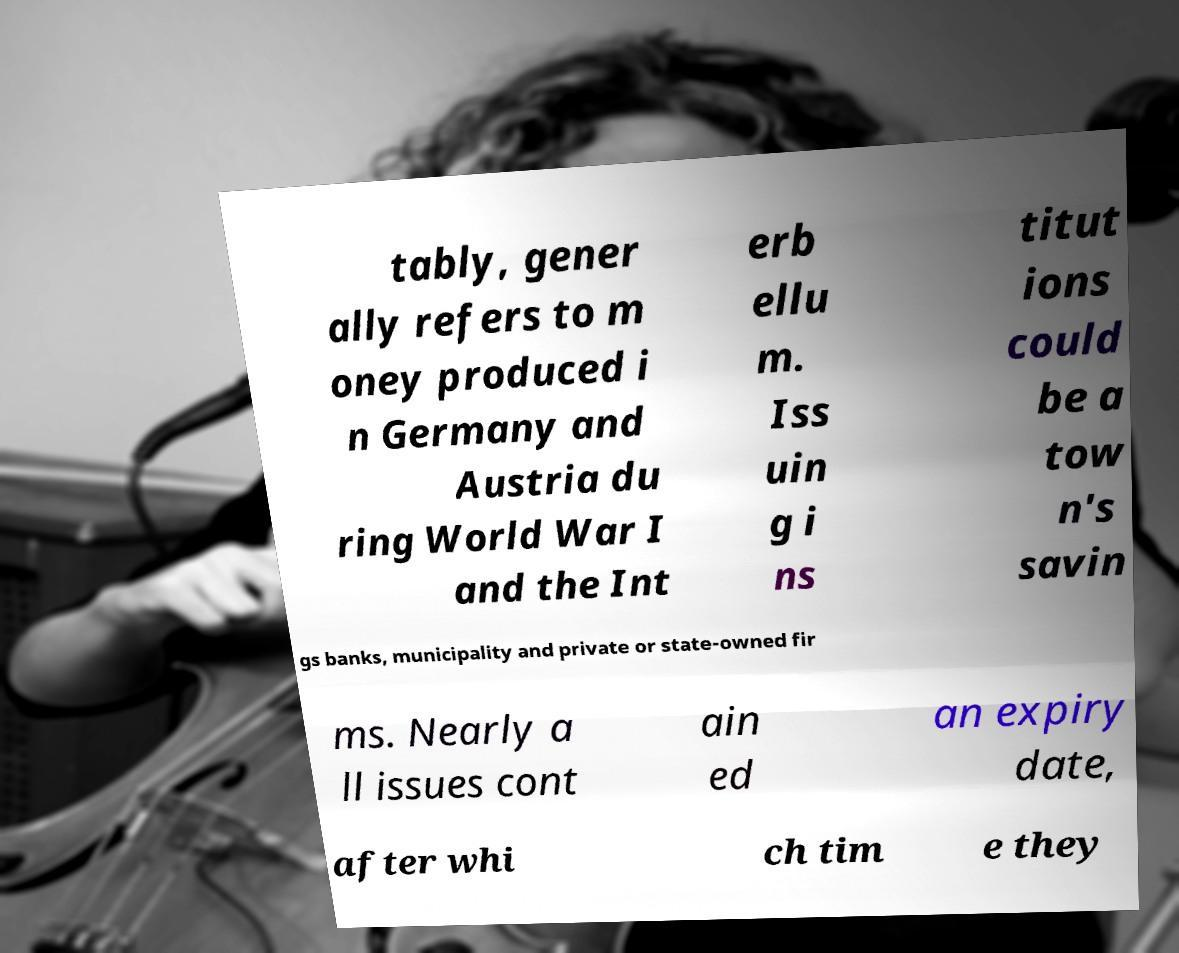Please read and relay the text visible in this image. What does it say? tably, gener ally refers to m oney produced i n Germany and Austria du ring World War I and the Int erb ellu m. Iss uin g i ns titut ions could be a tow n's savin gs banks, municipality and private or state-owned fir ms. Nearly a ll issues cont ain ed an expiry date, after whi ch tim e they 